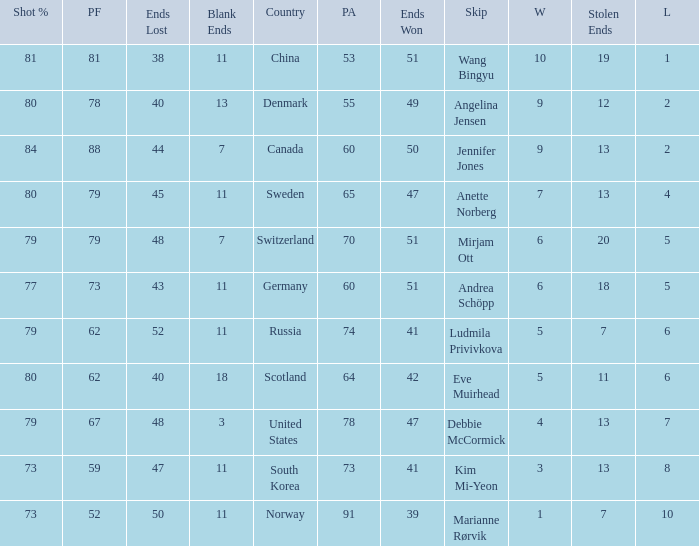What is Norway's least ends lost? 50.0. 